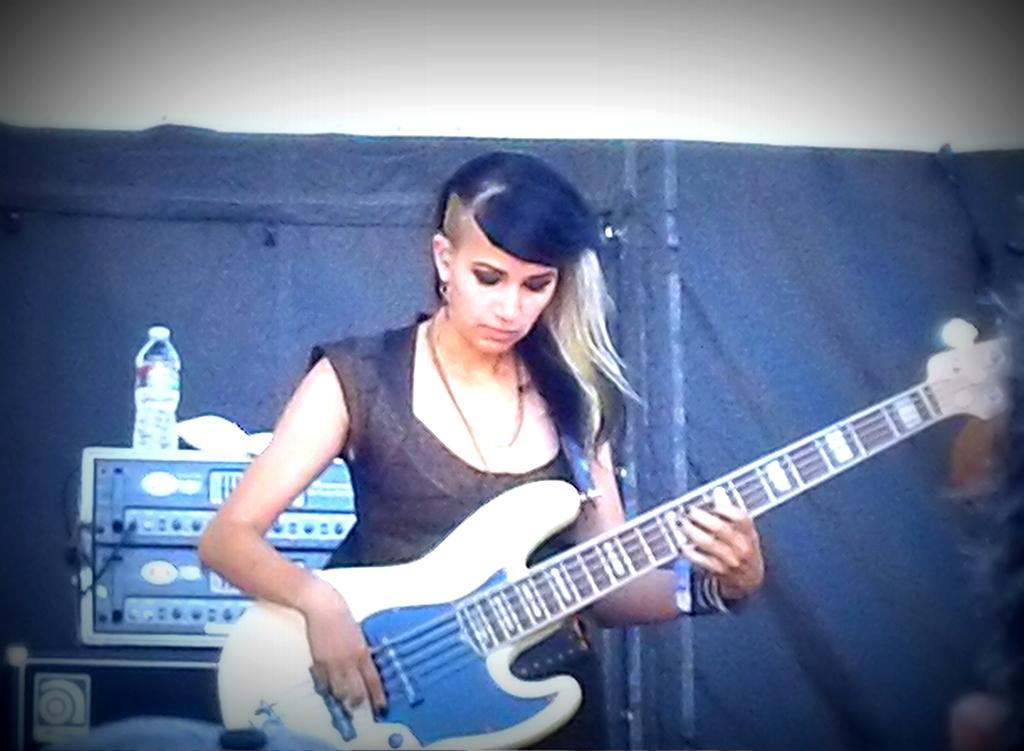Who is the main subject in the image? There is a woman in the image. Where is the woman positioned in the image? The woman is standing in the center of the image. What is the woman holding in her hand? The woman is holding a musical instrument in her hand. What can be seen in the background of the image? There is a black color sheet and machines visible in the background of the image. Can you identify any other objects in the background? Yes, there is a water bottle in the background of the image. What type of teeth can be seen in the image? There are no teeth visible in the image. Is there a party happening in the image? There is no indication of a party in the image. 